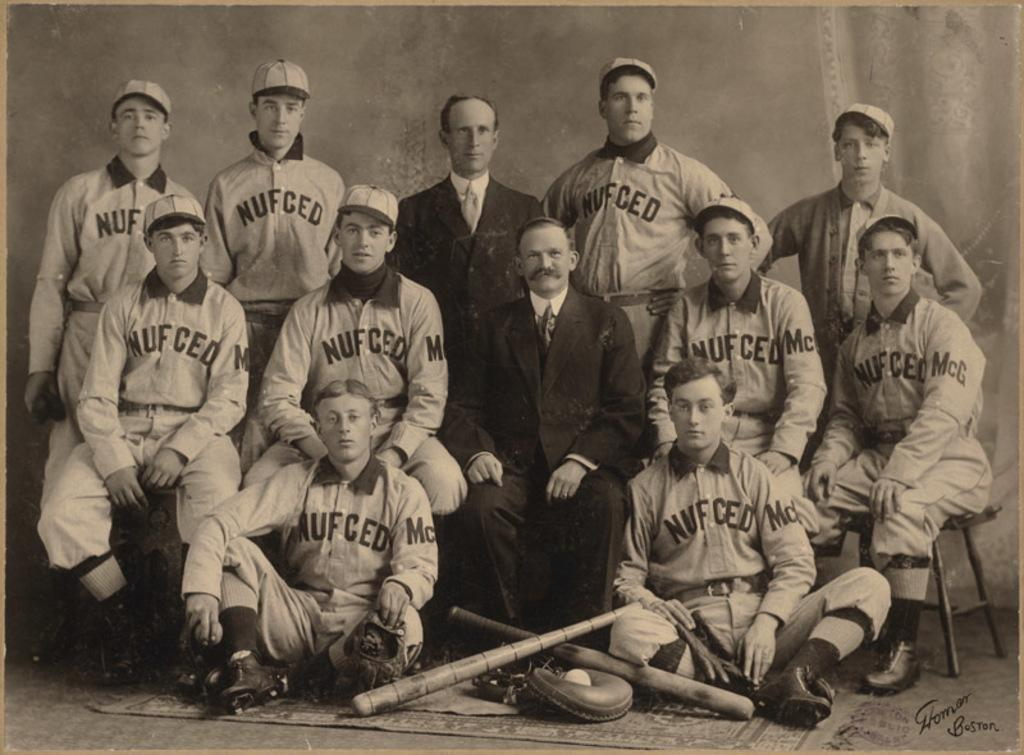<image>
Describe the image concisely. The team shown here is called the nufced 